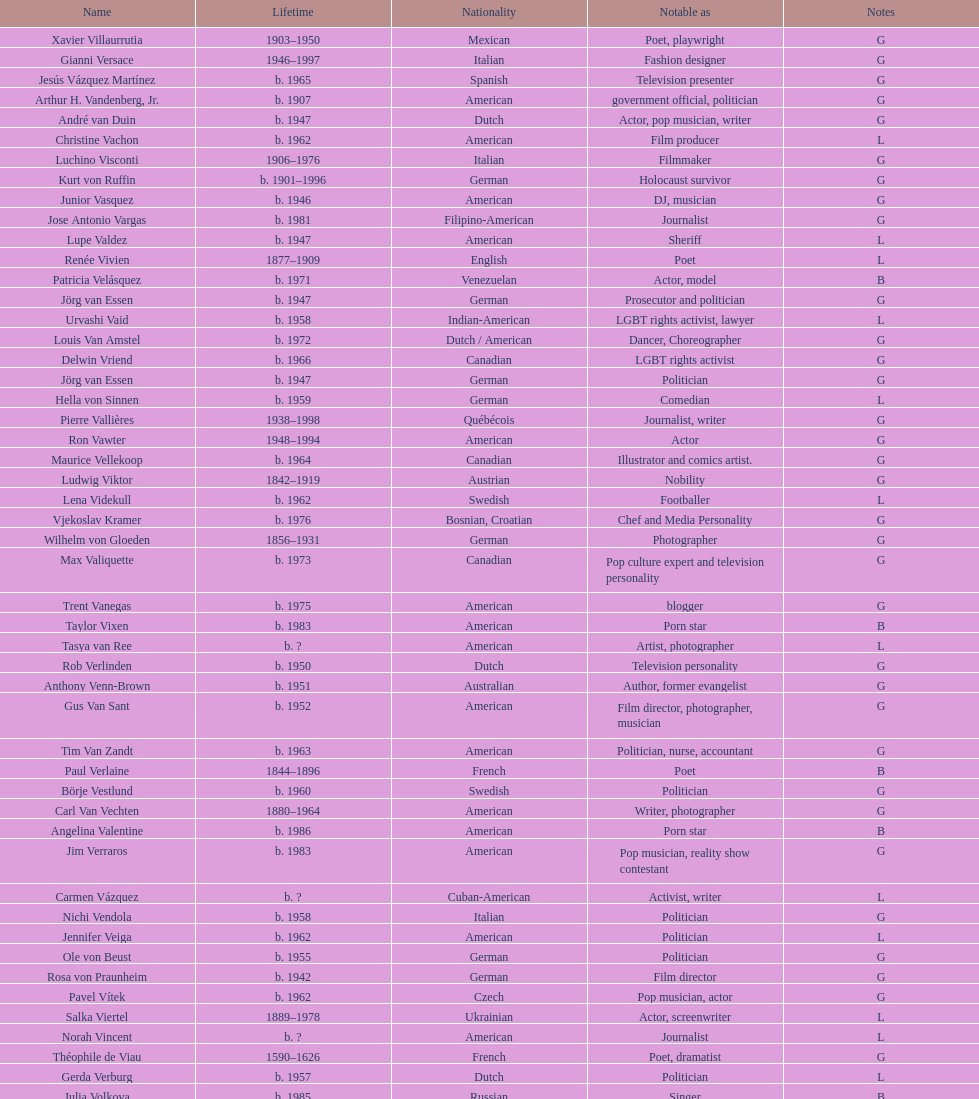Which is the previous name from lupe valdez Urvashi Vaid. 